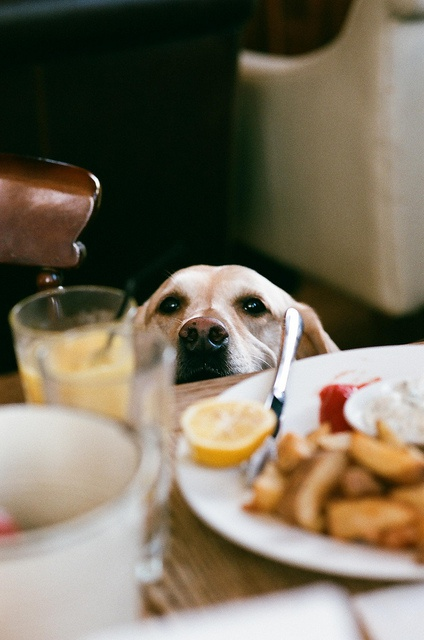Describe the objects in this image and their specific colors. I can see chair in black, gray, darkgray, and darkgreen tones, cup in black, lightgray, and darkgray tones, dog in black, lightgray, darkgray, and tan tones, dining table in black, maroon, and gray tones, and cup in black and tan tones in this image. 